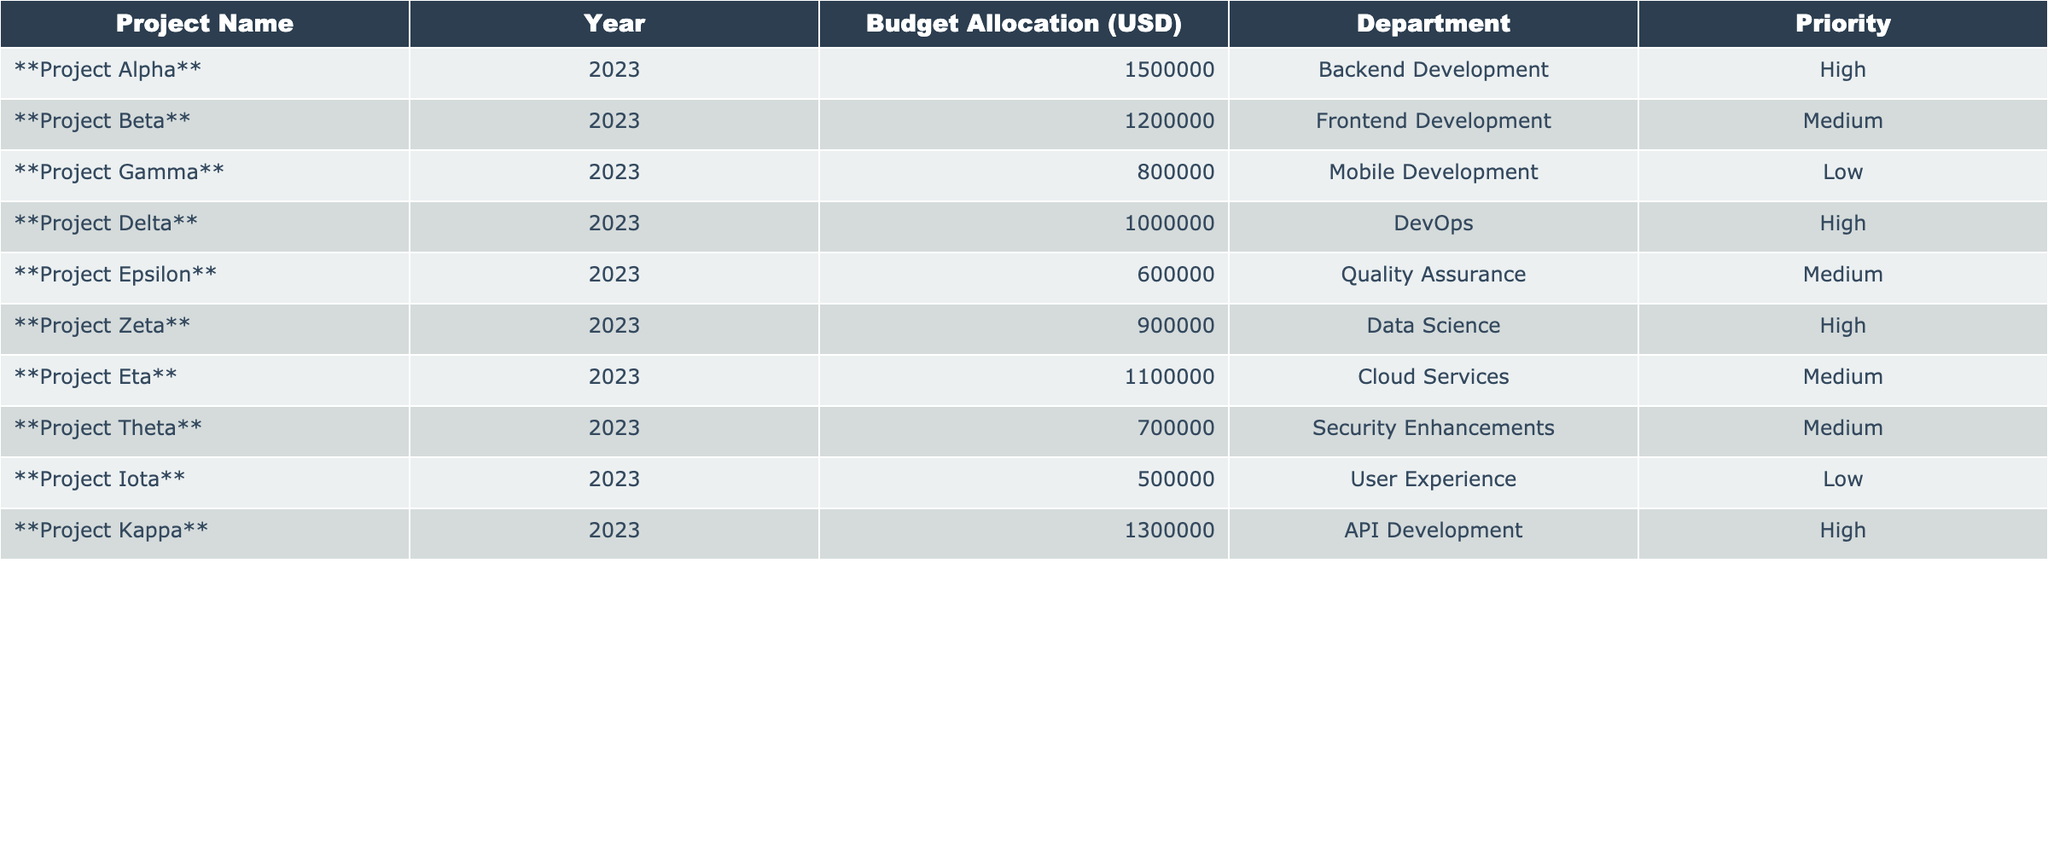What is the total budget allocation for high-priority projects? The high-priority projects are Project Alpha, Project Delta, Project Zeta, and Project Kappa. Their budget allocations are 1,500,000 + 1,000,000 + 900,000 + 1,300,000, which totals to 4,700,000 USD.
Answer: 4,700,000 Which project has the lowest budget allocation? The project with the lowest budget allocation is Project Iota, with a budget of 500,000 USD.
Answer: Project Iota How many projects are allocated a budget of over 1 million USD? The projects with budgets over 1 million USD are Project Alpha, Project Beta, Project Delta, Project Kappa, and Project Eta, totaling 5 projects.
Answer: 5 What percentage of the total budget is allocated to Project Theta? The total budget is calculated by summing all the allocations: 1,500,000 + 1,200,000 + 800,000 + 1,000,000 + 600,000 + 900,000 + 1,100,000 + 700,000 + 500,000 + 1,300,000 = 9,100,000 USD. Project Theta has a budget of 700,000 USD. Thus, the percentage is (700,000 / 9,100,000) * 100 ≈ 7.69%.
Answer: 7.69% What is the average budget allocation for medium-priority projects? The medium-priority projects are Project Beta, Project Epsilon, Project Eta, and Project Theta. Their budget allocations are 1,200,000, 600,000, 1,100,000, and 700,000. The total is 1,200,000 + 600,000 + 1,100,000 + 700,000 = 3,600,000. The average is 3,600,000 / 4 = 900,000 USD.
Answer: 900,000 Are there any projects related to mobile development? Yes, there is one project related to mobile development, which is Project Gamma.
Answer: Yes Which department received the highest budget allocation? The highest budget allocation is for the Backend Development department through Project Alpha, which received 1,500,000 USD.
Answer: Backend Development If you group projects by priority, how many projects fall into the low-priority category? The low-priority projects are Project Gamma and Project Iota. Therefore, there are 2 projects in the low-priority category.
Answer: 2 What is the total budget allocation for the Frontend Development department compared to the DevOps department? The Frontend Development department has Project Beta with 1,200,000 USD, and the DevOps department has Project Delta with 1,000,000 USD. Frontend Development has a higher total budget allocation of 1,200,000 compared to 1,000,000 for DevOps.
Answer: Frontend Development Which project has the highest budget allocation in the table? Project Alpha has the highest budget allocation of 1,500,000 USD.
Answer: Project Alpha Which department has the project with the greatest budget, and what is that budget? The department with the greatest budget is Backend Development with Project Alpha, which has a budget of 1,500,000 USD.
Answer: Backend Development, 1,500,000 